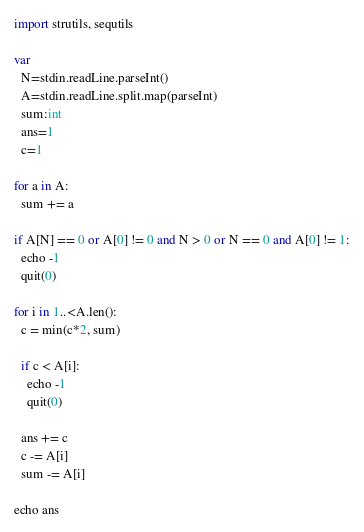<code> <loc_0><loc_0><loc_500><loc_500><_Nim_>import strutils, sequtils

var
  N=stdin.readLine.parseInt()
  A=stdin.readLine.split.map(parseInt)
  sum:int
  ans=1
  c=1

for a in A:
  sum += a

if A[N] == 0 or A[0] != 0 and N > 0 or N == 0 and A[0] != 1:
  echo -1
  quit(0)

for i in 1..<A.len():
  c = min(c*2, sum)
  
  if c < A[i]:
    echo -1
    quit(0)

  ans += c
  c -= A[i]
  sum -= A[i]

echo ans
</code> 